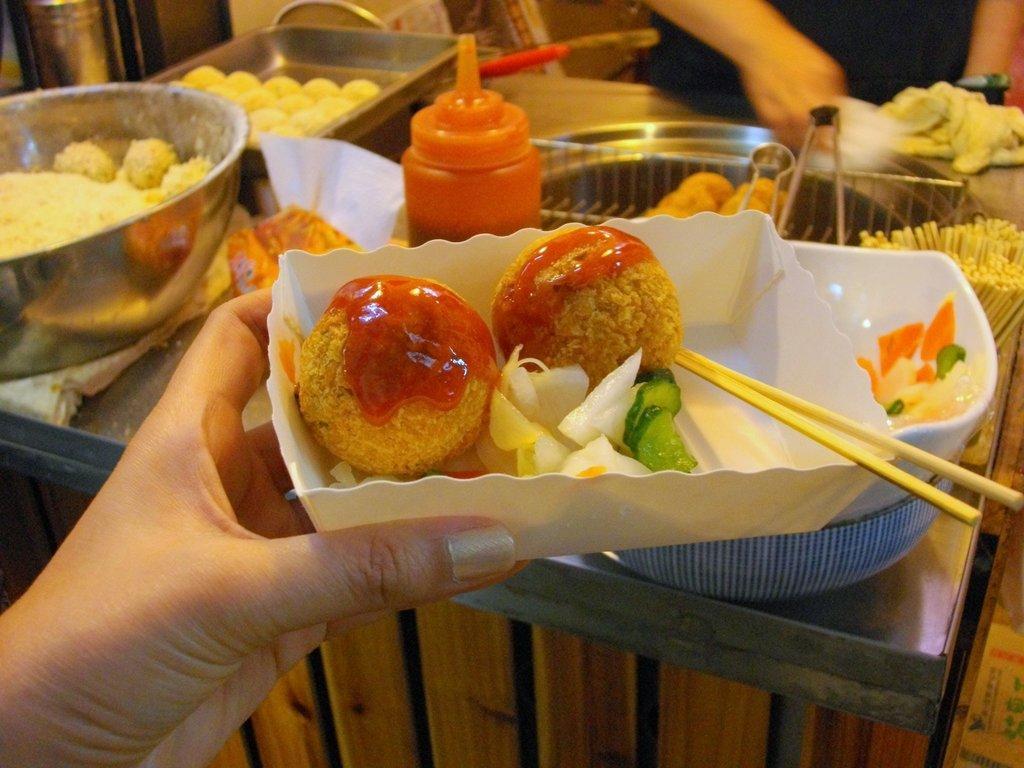Can you describe this image briefly? In this image there is a hand holding a paper cup, in that there is a food item, in the background there is a table, on that table there are trays and bowls in that there is a food item and a man standing near the table. 